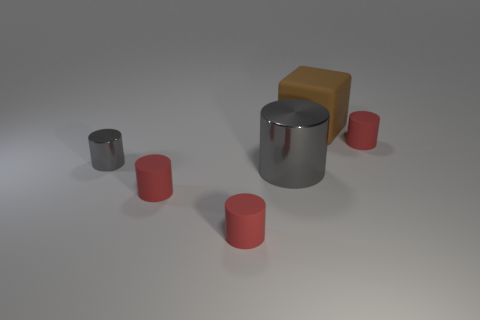Subtract all green blocks. How many red cylinders are left? 3 Subtract all big gray cylinders. How many cylinders are left? 4 Subtract all brown cylinders. Subtract all blue spheres. How many cylinders are left? 5 Add 2 big brown rubber cubes. How many objects exist? 8 Subtract all cylinders. How many objects are left? 1 Add 5 large objects. How many large objects exist? 7 Subtract 0 purple cubes. How many objects are left? 6 Subtract all big cyan rubber spheres. Subtract all red objects. How many objects are left? 3 Add 2 big rubber objects. How many big rubber objects are left? 3 